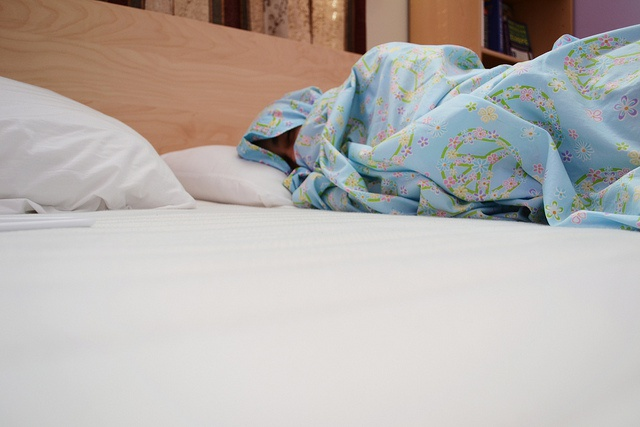Describe the objects in this image and their specific colors. I can see bed in lightgray, darkgray, brown, tan, and gray tones, people in brown, black, maroon, darkgray, and gray tones, book in black, darkgreen, and brown tones, book in black and brown tones, and book in brown, gray, black, and maroon tones in this image. 